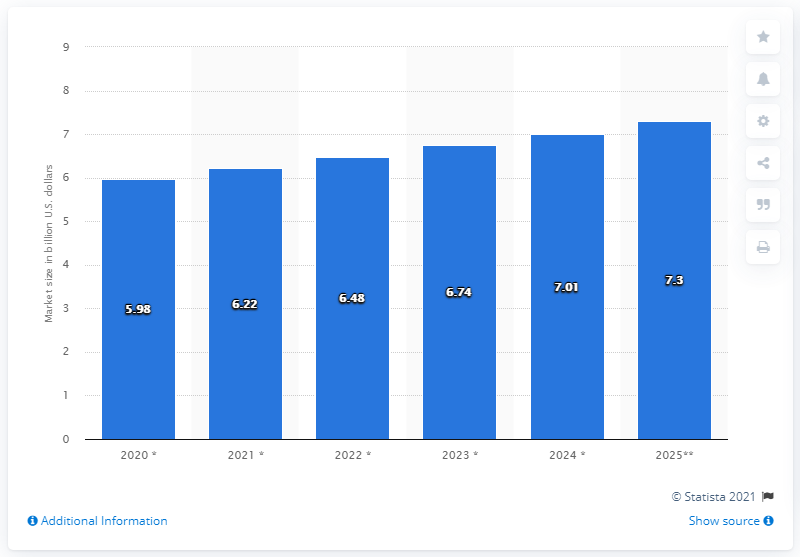Point out several critical features in this image. By 2025, the estimated value of the North American seasoning and spice market was projected to be approximately 7.3 billion dollars. 